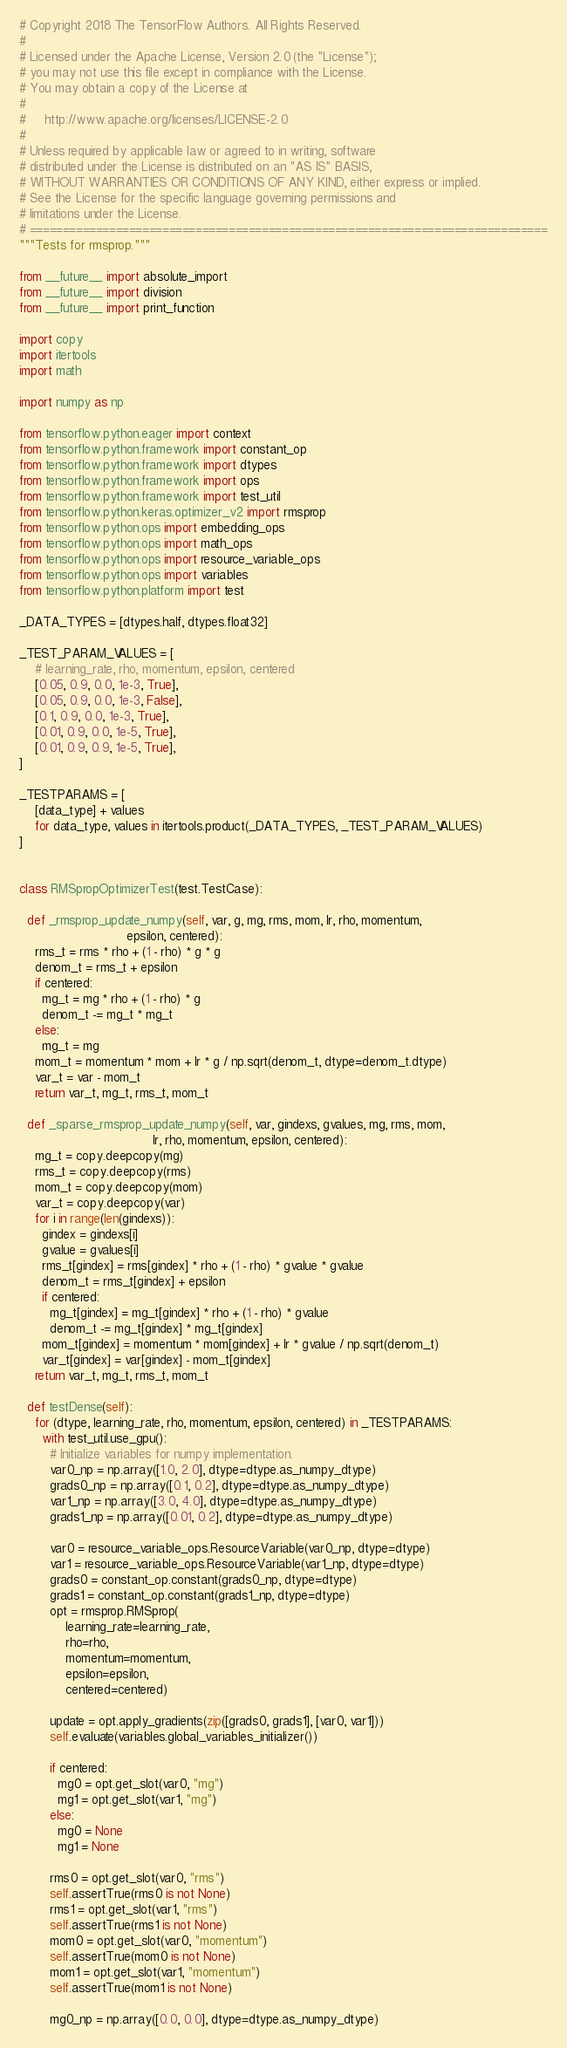Convert code to text. <code><loc_0><loc_0><loc_500><loc_500><_Python_># Copyright 2018 The TensorFlow Authors. All Rights Reserved.
#
# Licensed under the Apache License, Version 2.0 (the "License");
# you may not use this file except in compliance with the License.
# You may obtain a copy of the License at
#
#     http://www.apache.org/licenses/LICENSE-2.0
#
# Unless required by applicable law or agreed to in writing, software
# distributed under the License is distributed on an "AS IS" BASIS,
# WITHOUT WARRANTIES OR CONDITIONS OF ANY KIND, either express or implied.
# See the License for the specific language governing permissions and
# limitations under the License.
# ==============================================================================
"""Tests for rmsprop."""

from __future__ import absolute_import
from __future__ import division
from __future__ import print_function

import copy
import itertools
import math

import numpy as np

from tensorflow.python.eager import context
from tensorflow.python.framework import constant_op
from tensorflow.python.framework import dtypes
from tensorflow.python.framework import ops
from tensorflow.python.framework import test_util
from tensorflow.python.keras.optimizer_v2 import rmsprop
from tensorflow.python.ops import embedding_ops
from tensorflow.python.ops import math_ops
from tensorflow.python.ops import resource_variable_ops
from tensorflow.python.ops import variables
from tensorflow.python.platform import test

_DATA_TYPES = [dtypes.half, dtypes.float32]

_TEST_PARAM_VALUES = [
    # learning_rate, rho, momentum, epsilon, centered
    [0.05, 0.9, 0.0, 1e-3, True],
    [0.05, 0.9, 0.0, 1e-3, False],
    [0.1, 0.9, 0.0, 1e-3, True],
    [0.01, 0.9, 0.0, 1e-5, True],
    [0.01, 0.9, 0.9, 1e-5, True],
]

_TESTPARAMS = [
    [data_type] + values
    for data_type, values in itertools.product(_DATA_TYPES, _TEST_PARAM_VALUES)
]


class RMSpropOptimizerTest(test.TestCase):

  def _rmsprop_update_numpy(self, var, g, mg, rms, mom, lr, rho, momentum,
                            epsilon, centered):
    rms_t = rms * rho + (1 - rho) * g * g
    denom_t = rms_t + epsilon
    if centered:
      mg_t = mg * rho + (1 - rho) * g
      denom_t -= mg_t * mg_t
    else:
      mg_t = mg
    mom_t = momentum * mom + lr * g / np.sqrt(denom_t, dtype=denom_t.dtype)
    var_t = var - mom_t
    return var_t, mg_t, rms_t, mom_t

  def _sparse_rmsprop_update_numpy(self, var, gindexs, gvalues, mg, rms, mom,
                                   lr, rho, momentum, epsilon, centered):
    mg_t = copy.deepcopy(mg)
    rms_t = copy.deepcopy(rms)
    mom_t = copy.deepcopy(mom)
    var_t = copy.deepcopy(var)
    for i in range(len(gindexs)):
      gindex = gindexs[i]
      gvalue = gvalues[i]
      rms_t[gindex] = rms[gindex] * rho + (1 - rho) * gvalue * gvalue
      denom_t = rms_t[gindex] + epsilon
      if centered:
        mg_t[gindex] = mg_t[gindex] * rho + (1 - rho) * gvalue
        denom_t -= mg_t[gindex] * mg_t[gindex]
      mom_t[gindex] = momentum * mom[gindex] + lr * gvalue / np.sqrt(denom_t)
      var_t[gindex] = var[gindex] - mom_t[gindex]
    return var_t, mg_t, rms_t, mom_t

  def testDense(self):
    for (dtype, learning_rate, rho, momentum, epsilon, centered) in _TESTPARAMS:
      with test_util.use_gpu():
        # Initialize variables for numpy implementation.
        var0_np = np.array([1.0, 2.0], dtype=dtype.as_numpy_dtype)
        grads0_np = np.array([0.1, 0.2], dtype=dtype.as_numpy_dtype)
        var1_np = np.array([3.0, 4.0], dtype=dtype.as_numpy_dtype)
        grads1_np = np.array([0.01, 0.2], dtype=dtype.as_numpy_dtype)

        var0 = resource_variable_ops.ResourceVariable(var0_np, dtype=dtype)
        var1 = resource_variable_ops.ResourceVariable(var1_np, dtype=dtype)
        grads0 = constant_op.constant(grads0_np, dtype=dtype)
        grads1 = constant_op.constant(grads1_np, dtype=dtype)
        opt = rmsprop.RMSprop(
            learning_rate=learning_rate,
            rho=rho,
            momentum=momentum,
            epsilon=epsilon,
            centered=centered)

        update = opt.apply_gradients(zip([grads0, grads1], [var0, var1]))
        self.evaluate(variables.global_variables_initializer())

        if centered:
          mg0 = opt.get_slot(var0, "mg")
          mg1 = opt.get_slot(var1, "mg")
        else:
          mg0 = None
          mg1 = None

        rms0 = opt.get_slot(var0, "rms")
        self.assertTrue(rms0 is not None)
        rms1 = opt.get_slot(var1, "rms")
        self.assertTrue(rms1 is not None)
        mom0 = opt.get_slot(var0, "momentum")
        self.assertTrue(mom0 is not None)
        mom1 = opt.get_slot(var1, "momentum")
        self.assertTrue(mom1 is not None)

        mg0_np = np.array([0.0, 0.0], dtype=dtype.as_numpy_dtype)</code> 